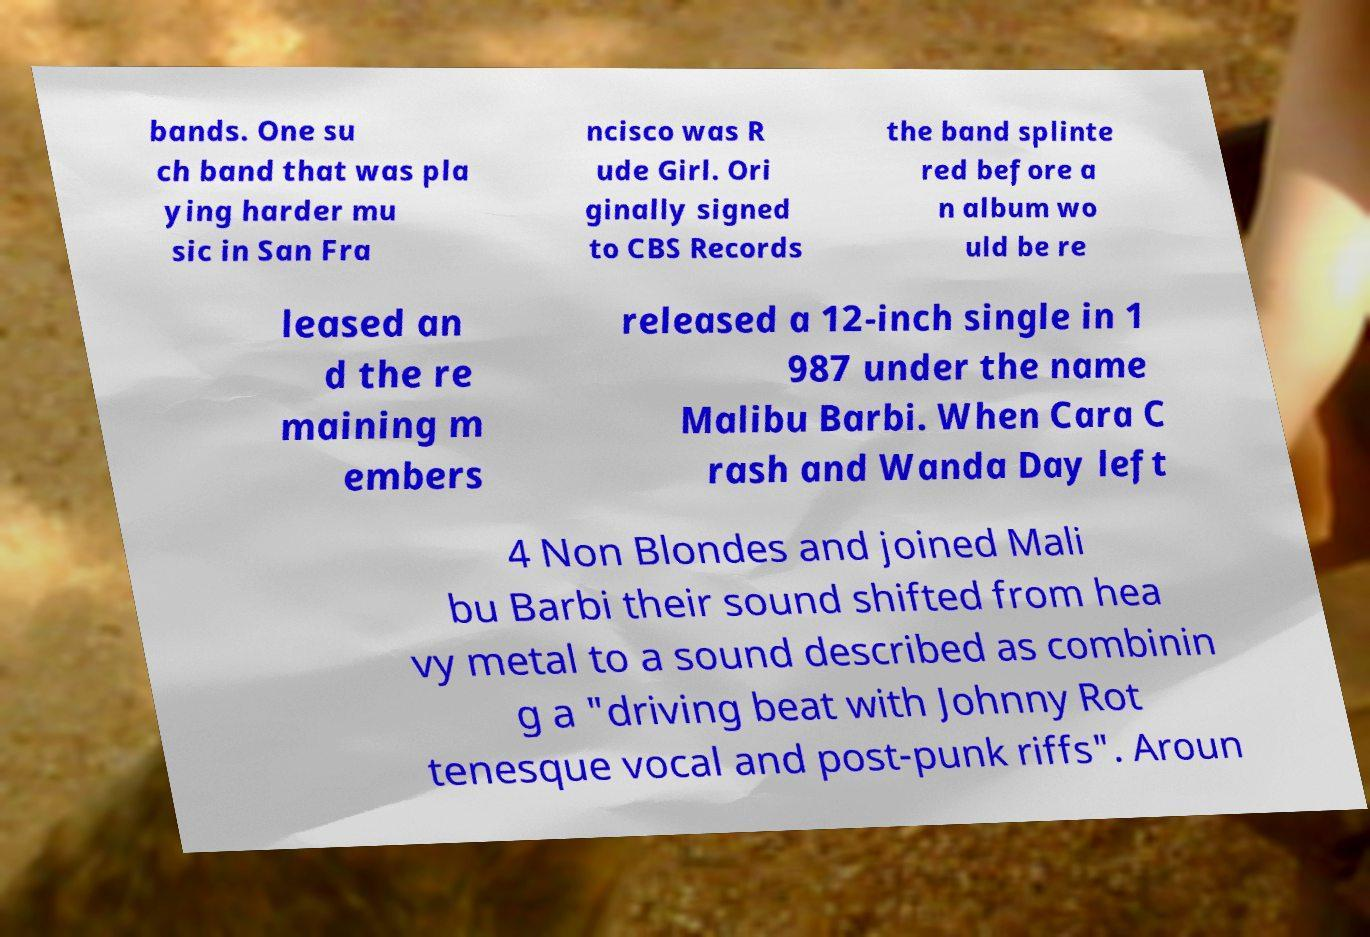Please identify and transcribe the text found in this image. bands. One su ch band that was pla ying harder mu sic in San Fra ncisco was R ude Girl. Ori ginally signed to CBS Records the band splinte red before a n album wo uld be re leased an d the re maining m embers released a 12-inch single in 1 987 under the name Malibu Barbi. When Cara C rash and Wanda Day left 4 Non Blondes and joined Mali bu Barbi their sound shifted from hea vy metal to a sound described as combinin g a "driving beat with Johnny Rot tenesque vocal and post-punk riffs". Aroun 